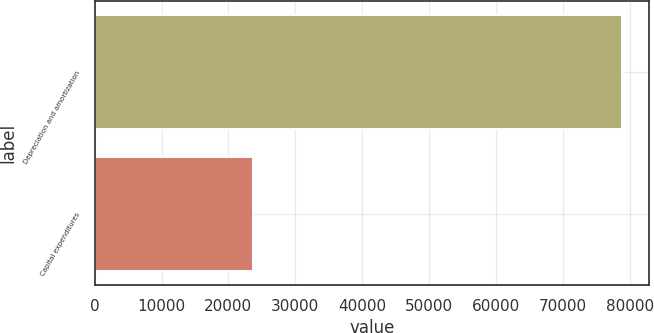<chart> <loc_0><loc_0><loc_500><loc_500><bar_chart><fcel>Depreciation and amortization<fcel>Capital expenditures<nl><fcel>78903<fcel>23738<nl></chart> 